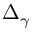<formula> <loc_0><loc_0><loc_500><loc_500>\Delta _ { \gamma }</formula> 